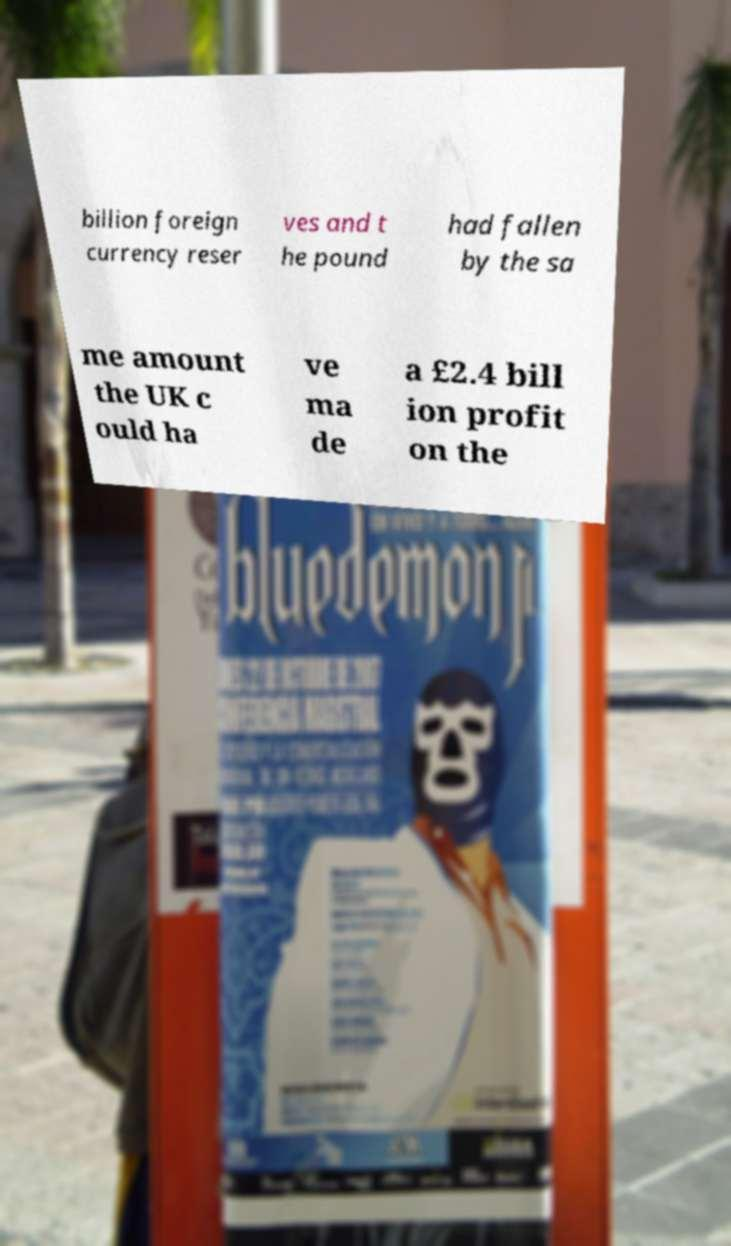Can you accurately transcribe the text from the provided image for me? billion foreign currency reser ves and t he pound had fallen by the sa me amount the UK c ould ha ve ma de a £2.4 bill ion profit on the 